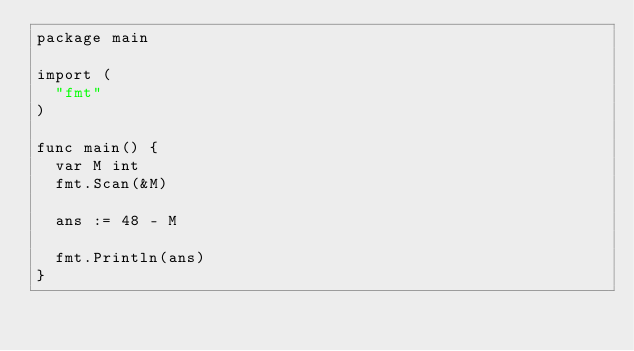Convert code to text. <code><loc_0><loc_0><loc_500><loc_500><_Go_>package main

import (
	"fmt"
)

func main() {
	var M int
	fmt.Scan(&M)

	ans := 48 - M

	fmt.Println(ans)
}</code> 